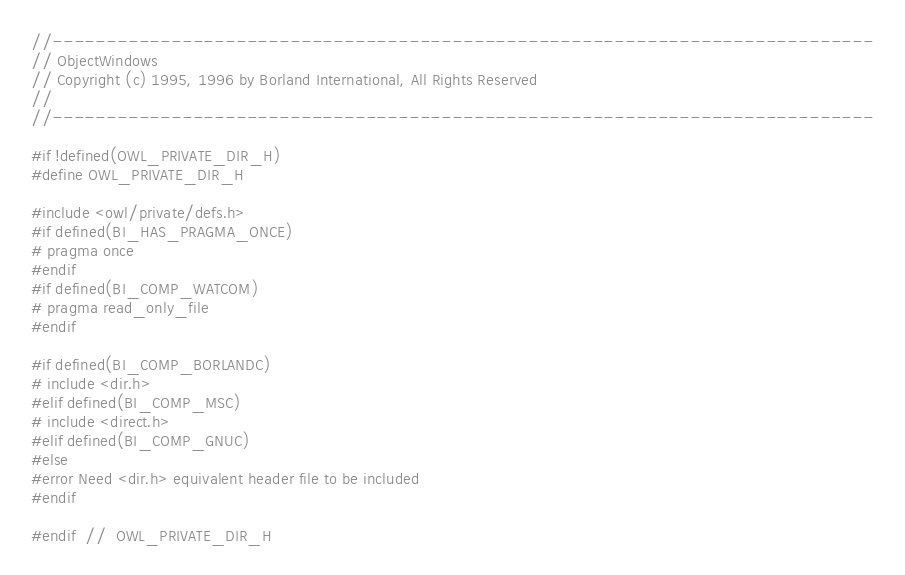<code> <loc_0><loc_0><loc_500><loc_500><_C_>//----------------------------------------------------------------------------
// ObjectWindows
// Copyright (c) 1995, 1996 by Borland International, All Rights Reserved
//
//----------------------------------------------------------------------------

#if !defined(OWL_PRIVATE_DIR_H)
#define OWL_PRIVATE_DIR_H

#include <owl/private/defs.h>
#if defined(BI_HAS_PRAGMA_ONCE)
# pragma once
#endif
#if defined(BI_COMP_WATCOM)
# pragma read_only_file
#endif

#if defined(BI_COMP_BORLANDC)
# include <dir.h>
#elif defined(BI_COMP_MSC)
# include <direct.h>
#elif defined(BI_COMP_GNUC)
#else
#error Need <dir.h> equivalent header file to be included
#endif

#endif  //  OWL_PRIVATE_DIR_H

</code> 